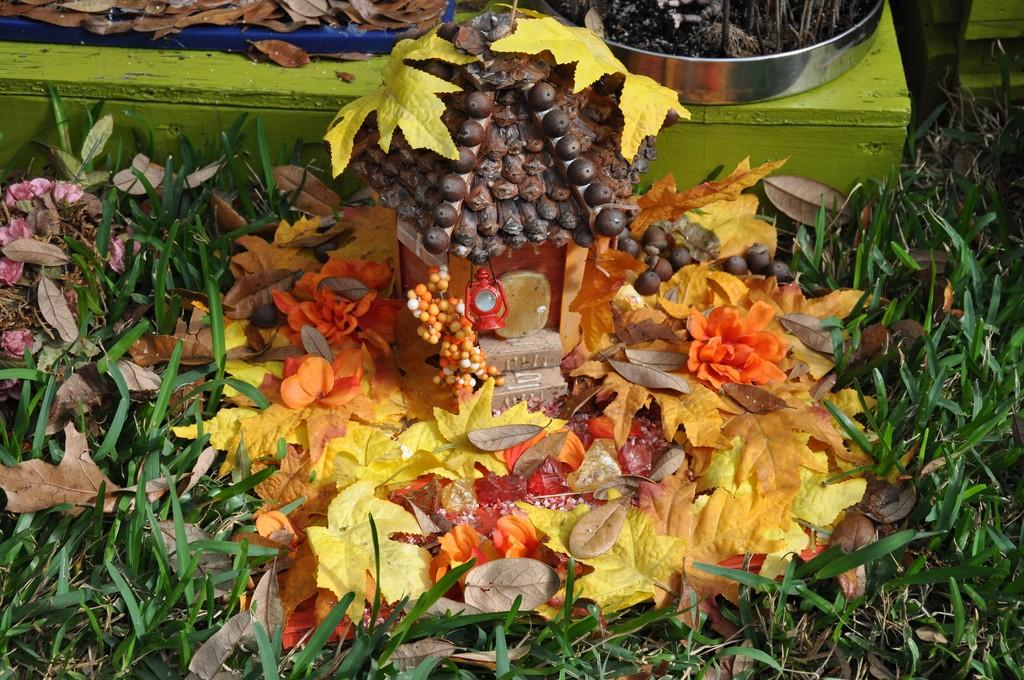What is the main feature in the center of the image? There is a decorative element in the center of the image. What type of natural elements can be seen at the bottom of the image? Leaves and grass are present at the bottom of the image. Can you identify any objects related to plant care in the image? Yes, there is a flower pot in the image. What type of kettle is used for learning to balance in the image? There is no kettle or any activity related to learning or balance present in the image. 